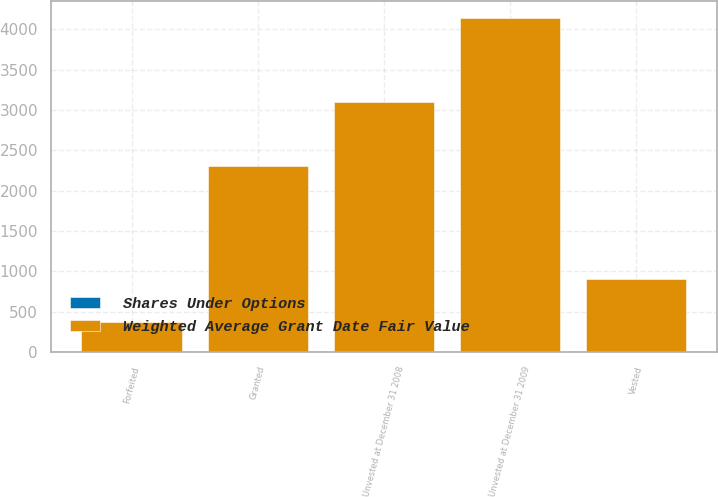Convert chart to OTSL. <chart><loc_0><loc_0><loc_500><loc_500><stacked_bar_chart><ecel><fcel>Unvested at December 31 2008<fcel>Granted<fcel>Vested<fcel>Forfeited<fcel>Unvested at December 31 2009<nl><fcel>Weighted Average Grant Date Fair Value<fcel>3099<fcel>2310<fcel>902<fcel>368<fcel>4139<nl><fcel>Shares Under Options<fcel>2.95<fcel>2.23<fcel>2.64<fcel>2.88<fcel>2.59<nl></chart> 